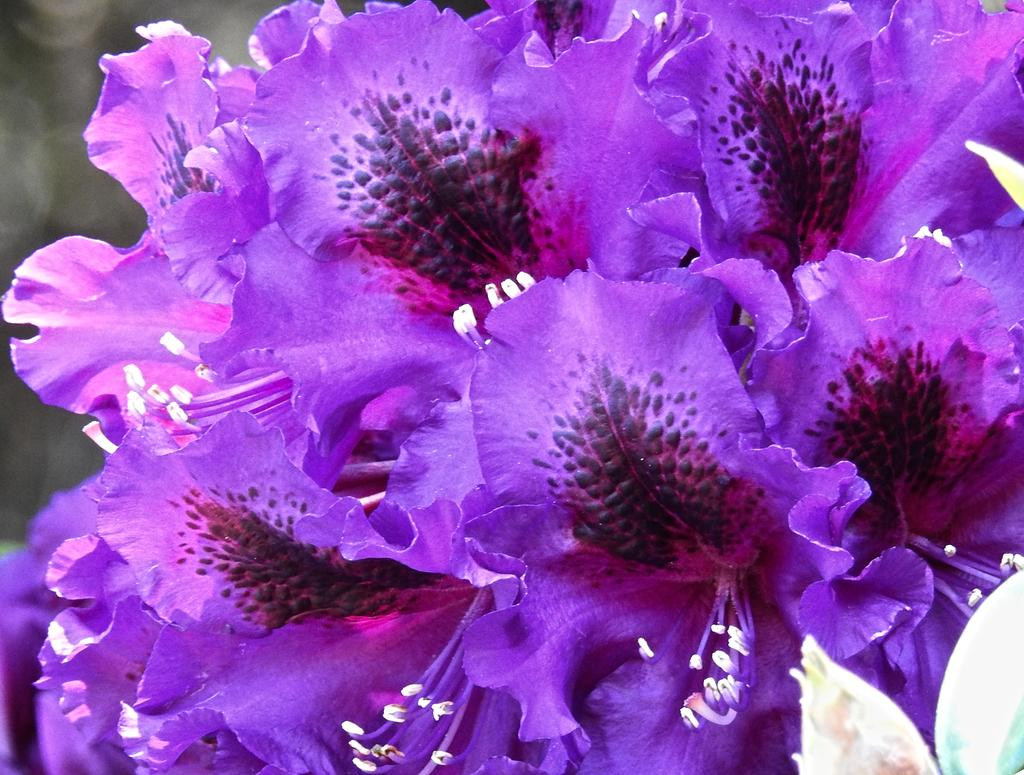What type of living organisms can be seen in the image? There are flowers in the image. Can you describe the background of the image? The background of the image is blurred. What news headline is visible on the flowers in the image? There is no news headline present on the flowers in the image. 